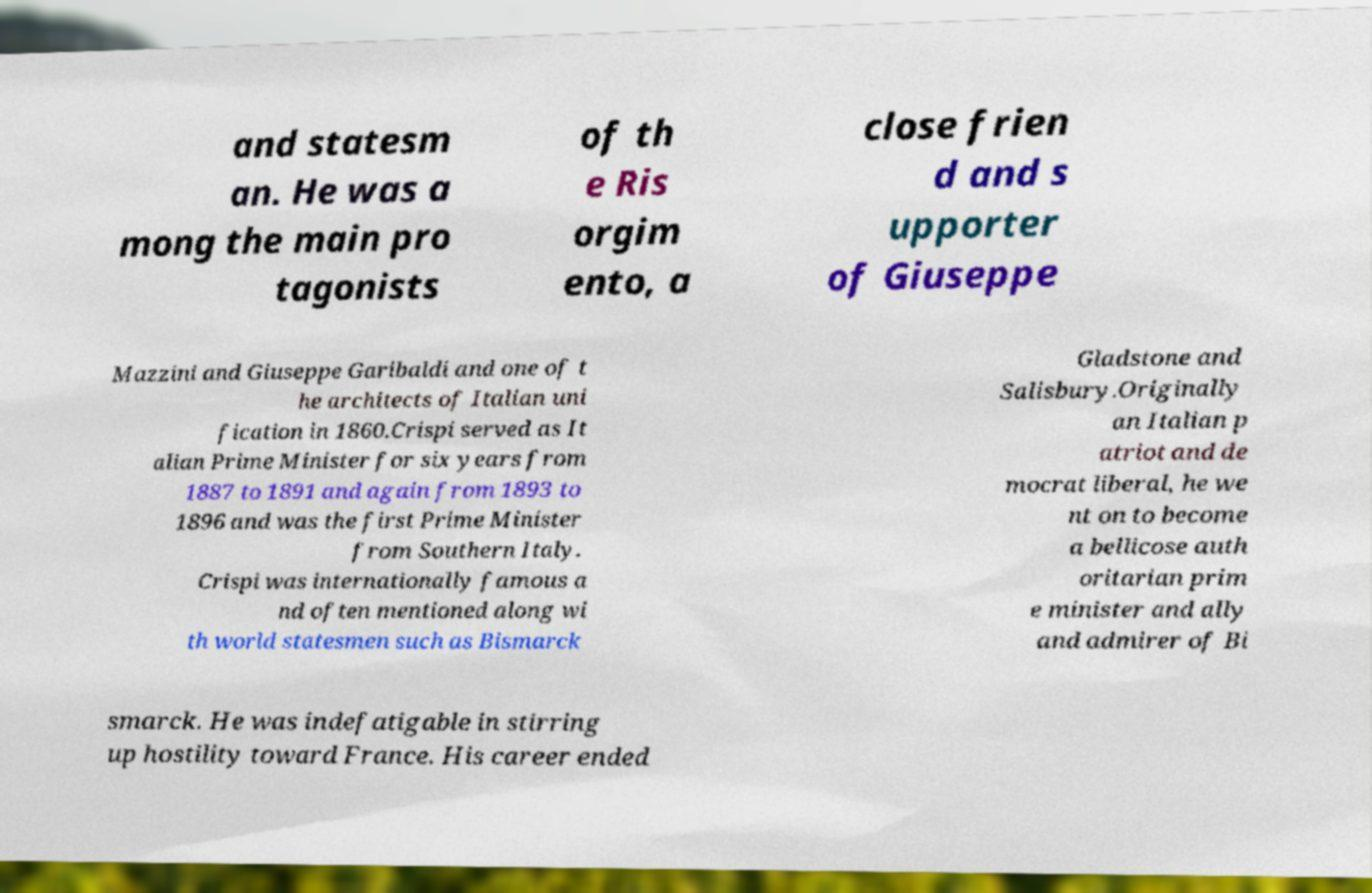What messages or text are displayed in this image? I need them in a readable, typed format. and statesm an. He was a mong the main pro tagonists of th e Ris orgim ento, a close frien d and s upporter of Giuseppe Mazzini and Giuseppe Garibaldi and one of t he architects of Italian uni fication in 1860.Crispi served as It alian Prime Minister for six years from 1887 to 1891 and again from 1893 to 1896 and was the first Prime Minister from Southern Italy. Crispi was internationally famous a nd often mentioned along wi th world statesmen such as Bismarck Gladstone and Salisbury.Originally an Italian p atriot and de mocrat liberal, he we nt on to become a bellicose auth oritarian prim e minister and ally and admirer of Bi smarck. He was indefatigable in stirring up hostility toward France. His career ended 